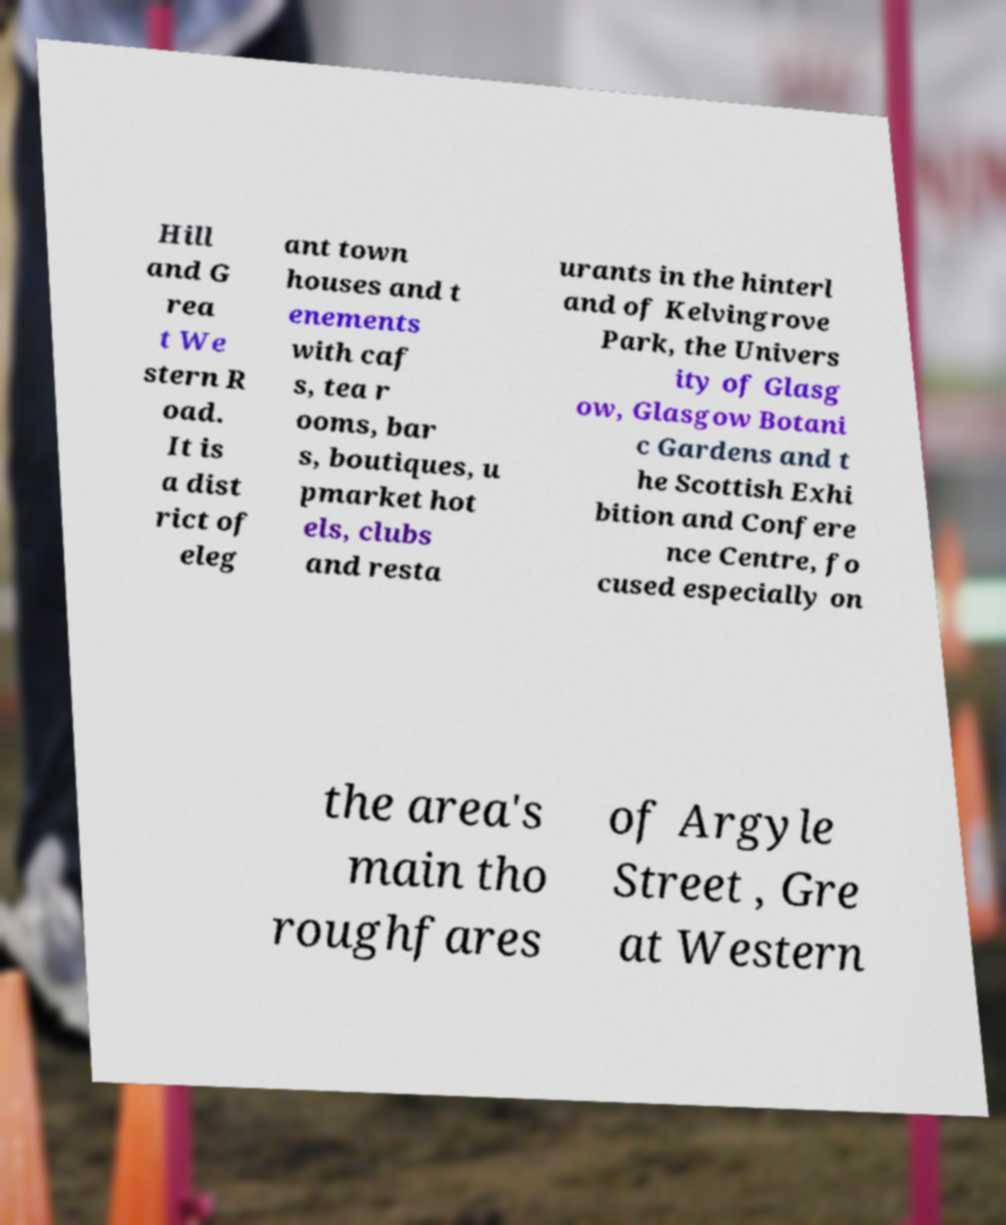Could you extract and type out the text from this image? Hill and G rea t We stern R oad. It is a dist rict of eleg ant town houses and t enements with caf s, tea r ooms, bar s, boutiques, u pmarket hot els, clubs and resta urants in the hinterl and of Kelvingrove Park, the Univers ity of Glasg ow, Glasgow Botani c Gardens and t he Scottish Exhi bition and Confere nce Centre, fo cused especially on the area's main tho roughfares of Argyle Street , Gre at Western 